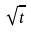Convert formula to latex. <formula><loc_0><loc_0><loc_500><loc_500>\sqrt { t }</formula> 